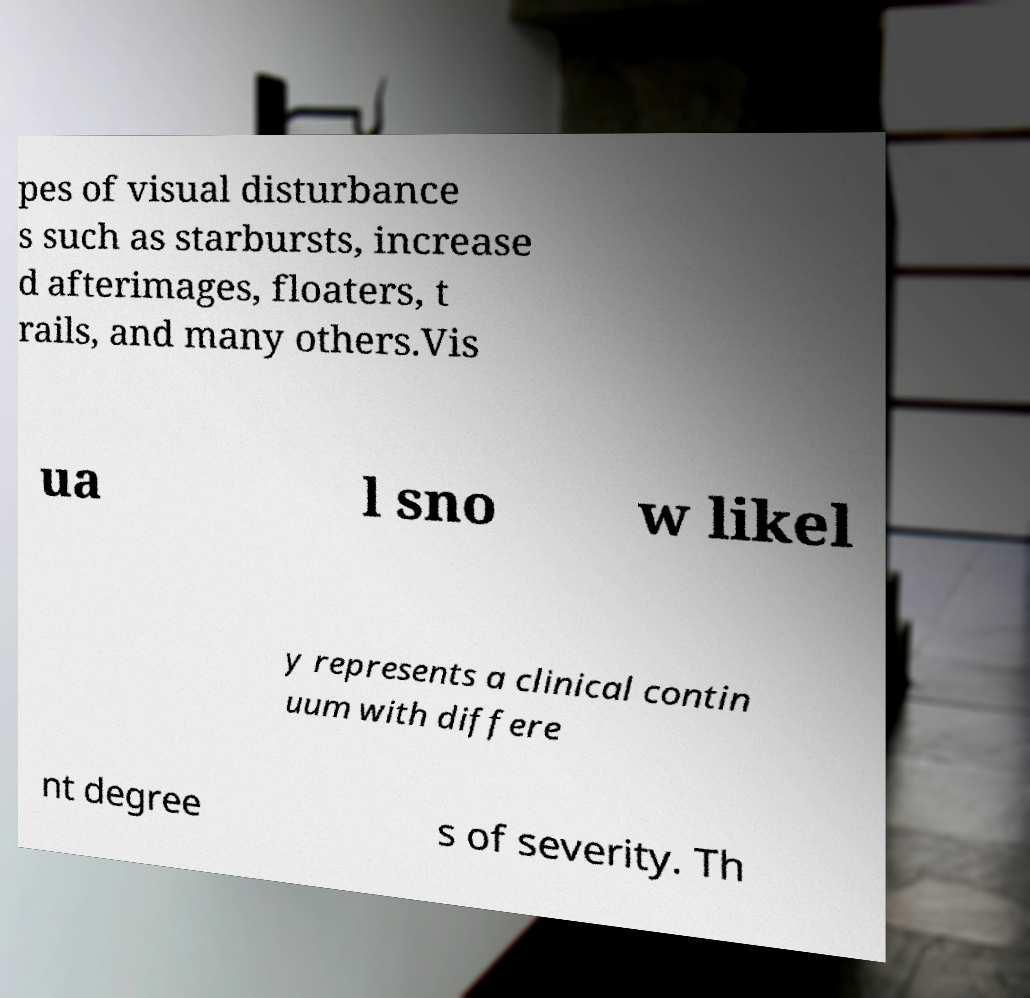I need the written content from this picture converted into text. Can you do that? pes of visual disturbance s such as starbursts, increase d afterimages, floaters, t rails, and many others.Vis ua l sno w likel y represents a clinical contin uum with differe nt degree s of severity. Th 